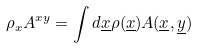Convert formula to latex. <formula><loc_0><loc_0><loc_500><loc_500>\rho _ { x } A ^ { x y } = \int d \underline { x } \rho ( \underline { x } ) A ( \underline { x } , \underline { y } )</formula> 